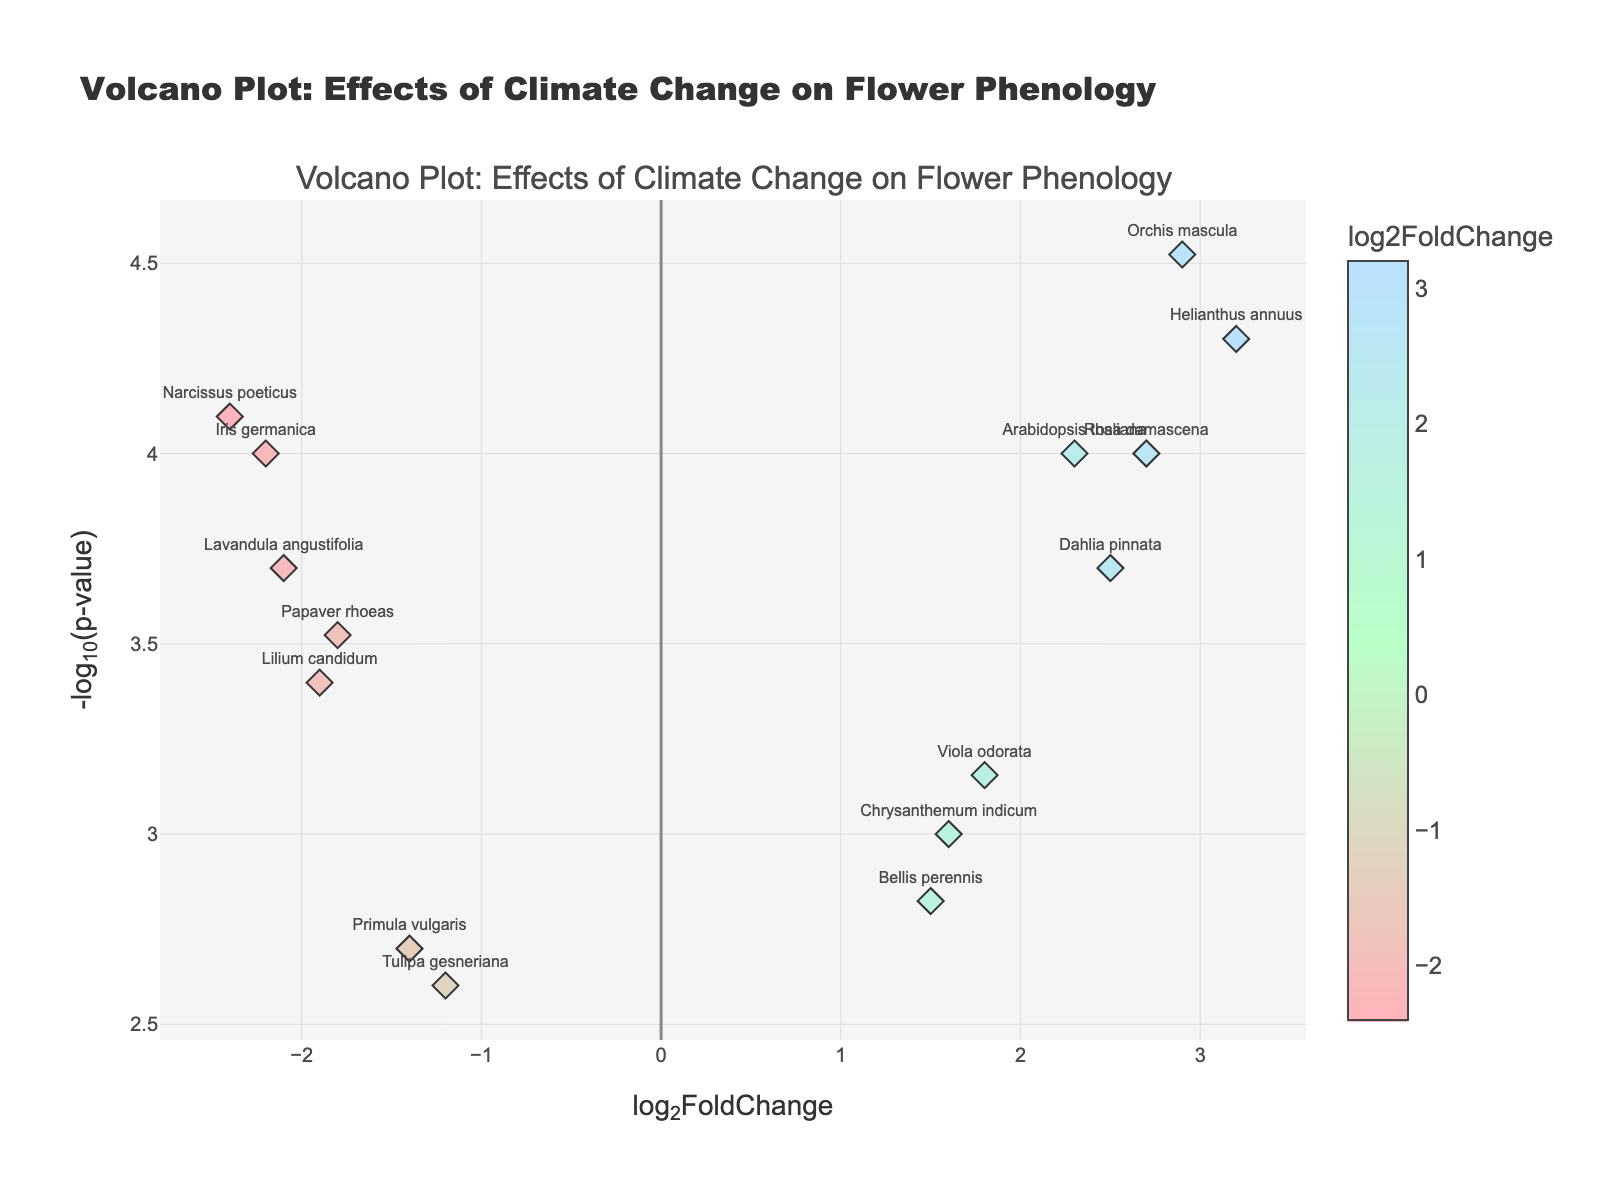Which flower species shows the highest positive log2FoldChange? The flower species with the highest positive log2FoldChange corresponds to the point furthest to the right on the x-axis.
Answer: Helianthus annuus Which flower species has the lowest p-value? The flower species with the lowest p-value corresponds to the point highest up on the y-axis.
Answer: Orchis mascula How many flower species have a log2FoldChange greater than 2? By counting the points to the right of the x-axis mark for log2FoldChange of 2.
Answer: 3 Which flower species show a negative log2FoldChange? The flower species with a negative log2FoldChange are those with points to the left of the y-axis.
Answer: Papaver rhoeas, Lavandula angustifolia, Tulipa gesneriana, Lilium candidum, Narcissus poeticus, Primula vulgaris, Iris germanica What is the general trend between log2FoldChange and -log10(p-value) for the flower species? Observing the spread of the points on the plot, a general trend or lack thereof between x and y axes can be noted.
Answer: No clear trend What is the -log10(p-value) for Bellis perennis? Reading off the y-coordinate value of the point labeled "Bellis perennis".
Answer: -log10(0.0015) Which flower species has the closest positive log2FoldChange to zero? Looking at the points just right of the y-axis, identify the closest.
Answer: Bellis perennis Compare the -log10(p-value) of Narcissus poeticus and Iris germanica. Which one is higher? By comparing the y-coordinates of the points labeled "Narcissus poeticus" and "Iris germanica".
Answer: Narcissus poeticus What is the average log2FoldChange for all the flower species? Sum the log2FoldChange of all flower species and divide by the total number of species (14). The sum is 8.7, so the average is 8.7/14.
Answer: 0.62 